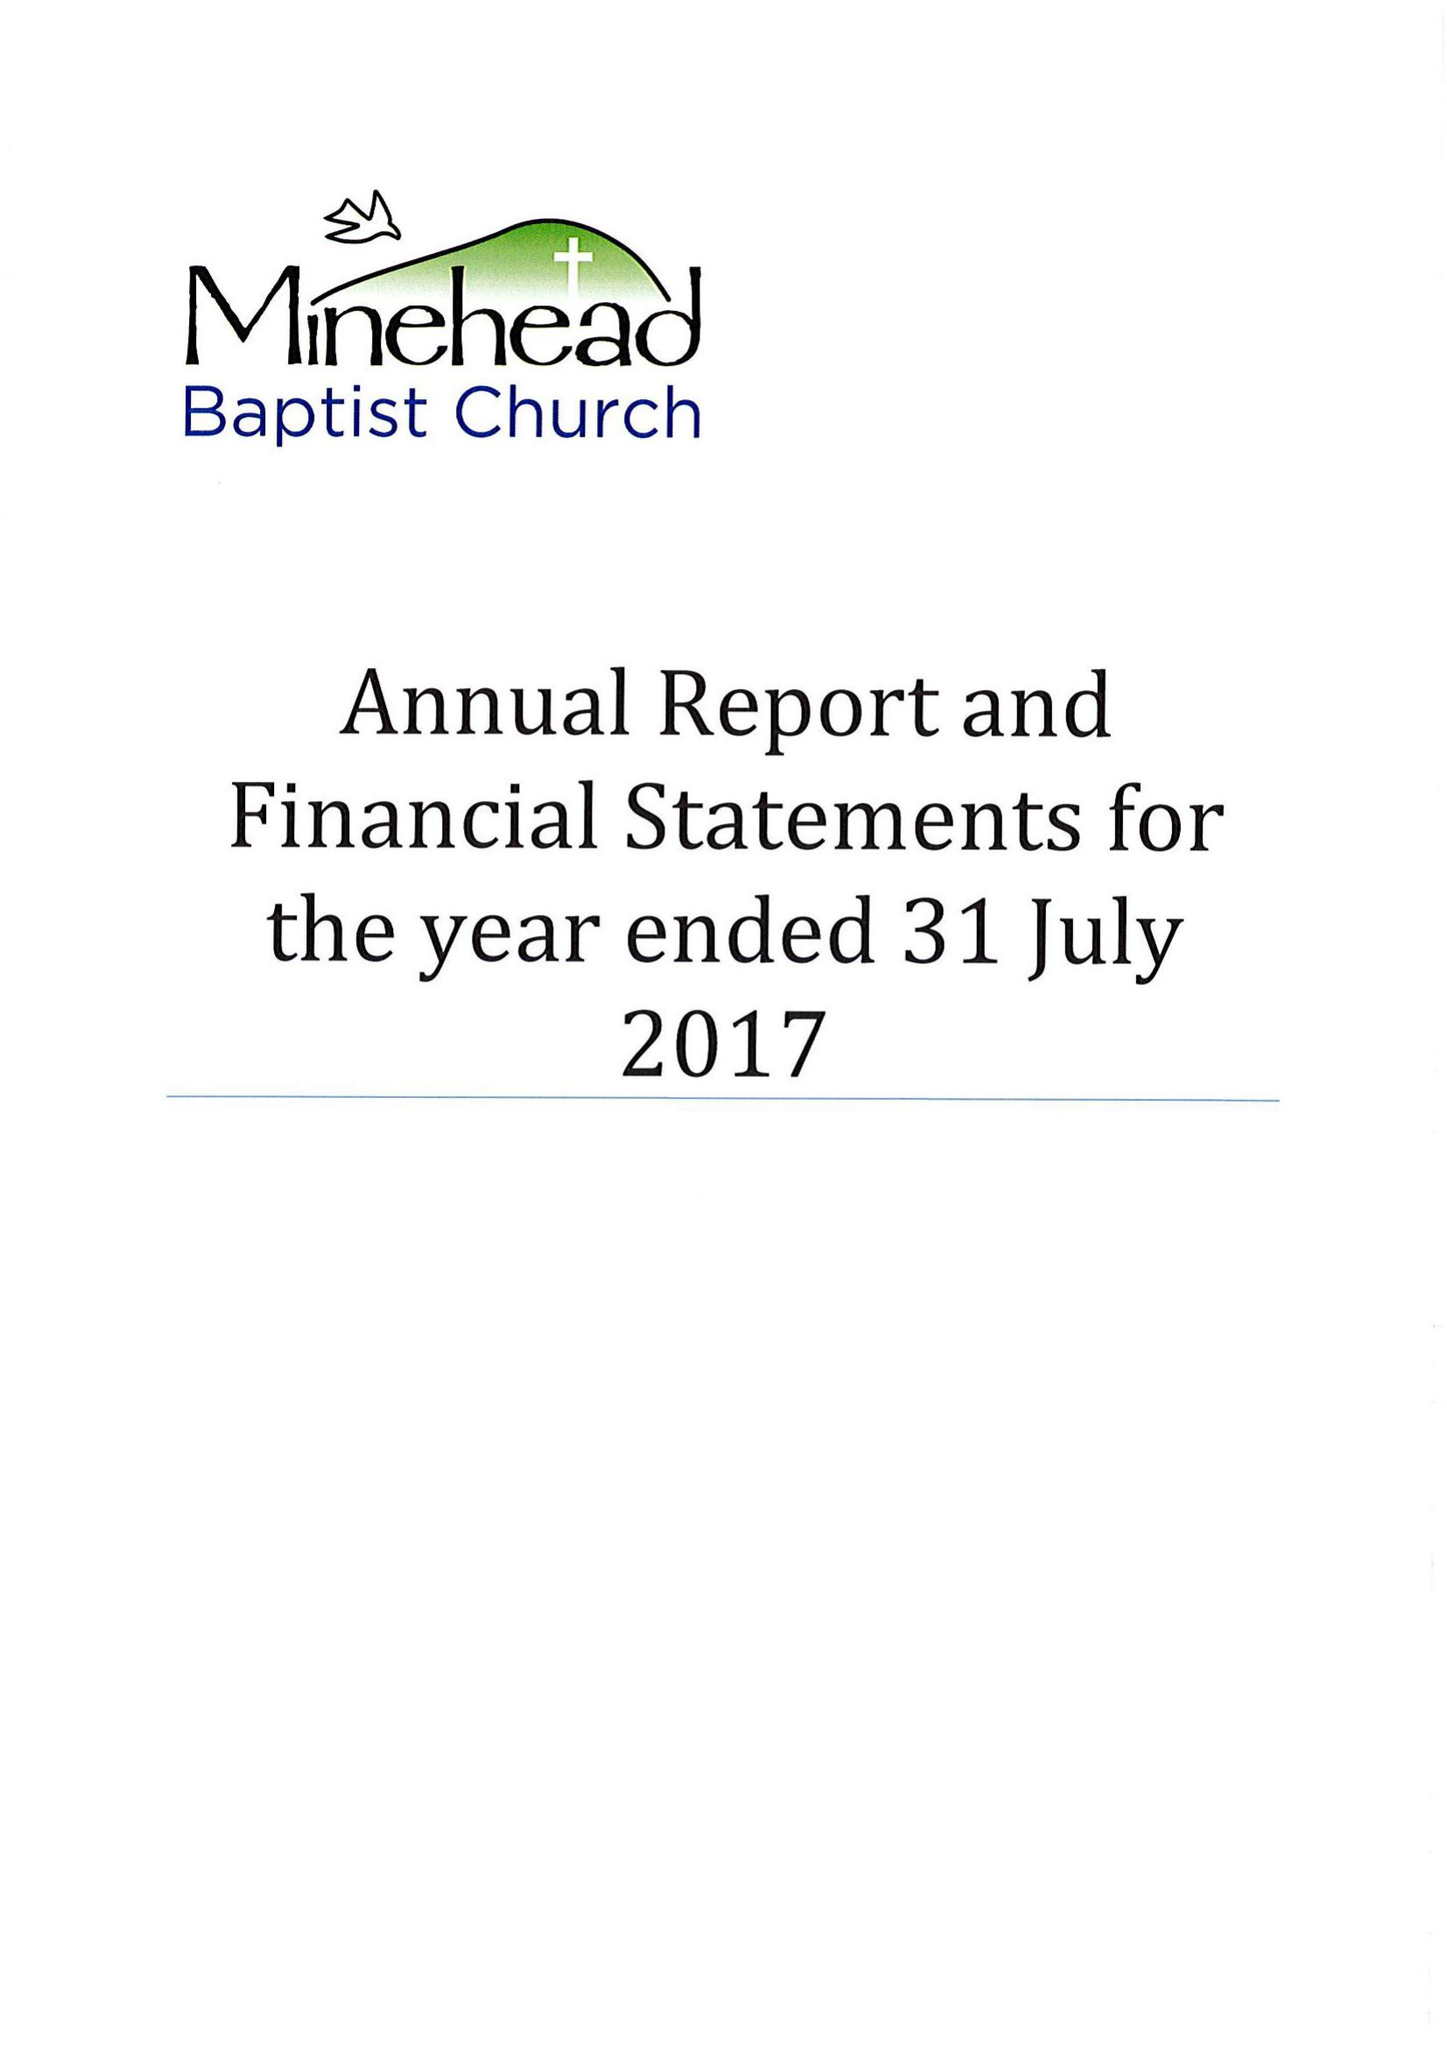What is the value for the income_annually_in_british_pounds?
Answer the question using a single word or phrase. 294116.00 